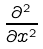<formula> <loc_0><loc_0><loc_500><loc_500>\frac { \partial ^ { 2 } } { \partial x ^ { 2 } }</formula> 